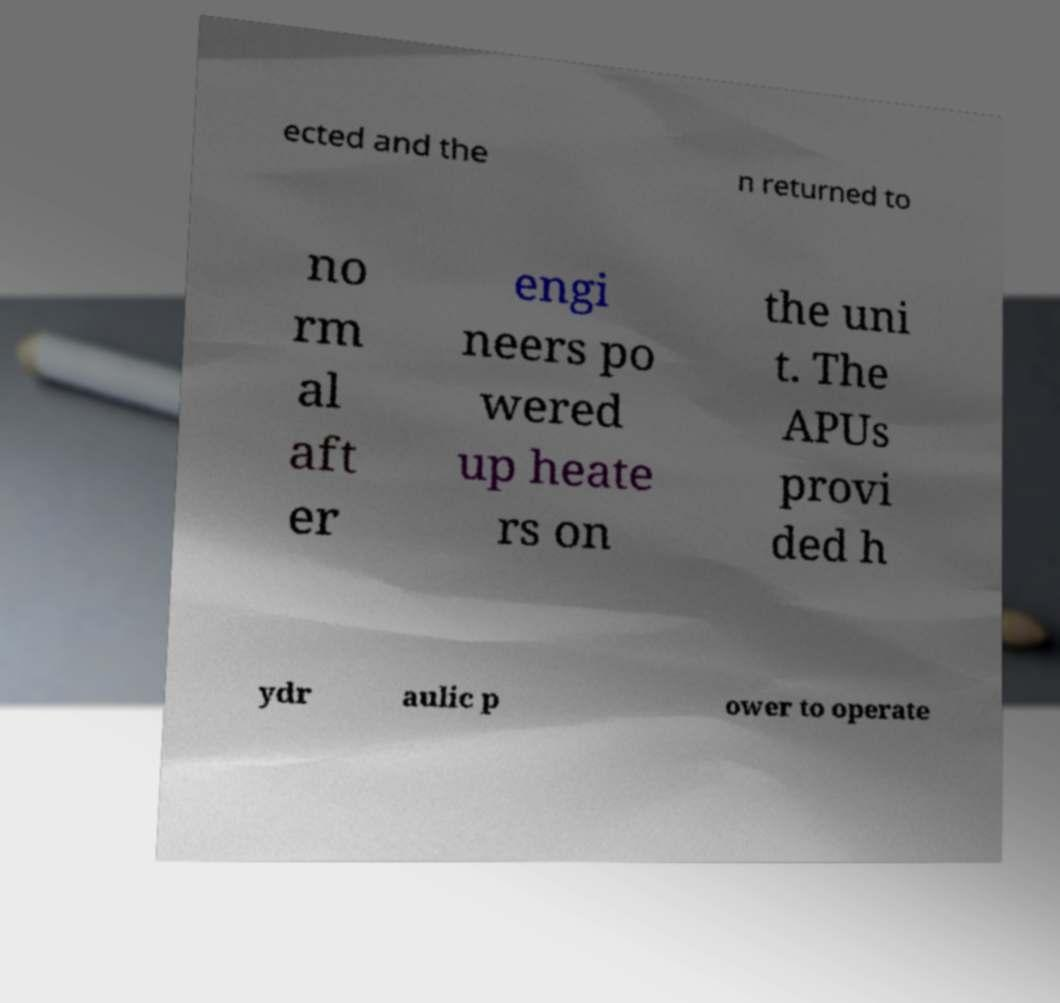There's text embedded in this image that I need extracted. Can you transcribe it verbatim? ected and the n returned to no rm al aft er engi neers po wered up heate rs on the uni t. The APUs provi ded h ydr aulic p ower to operate 